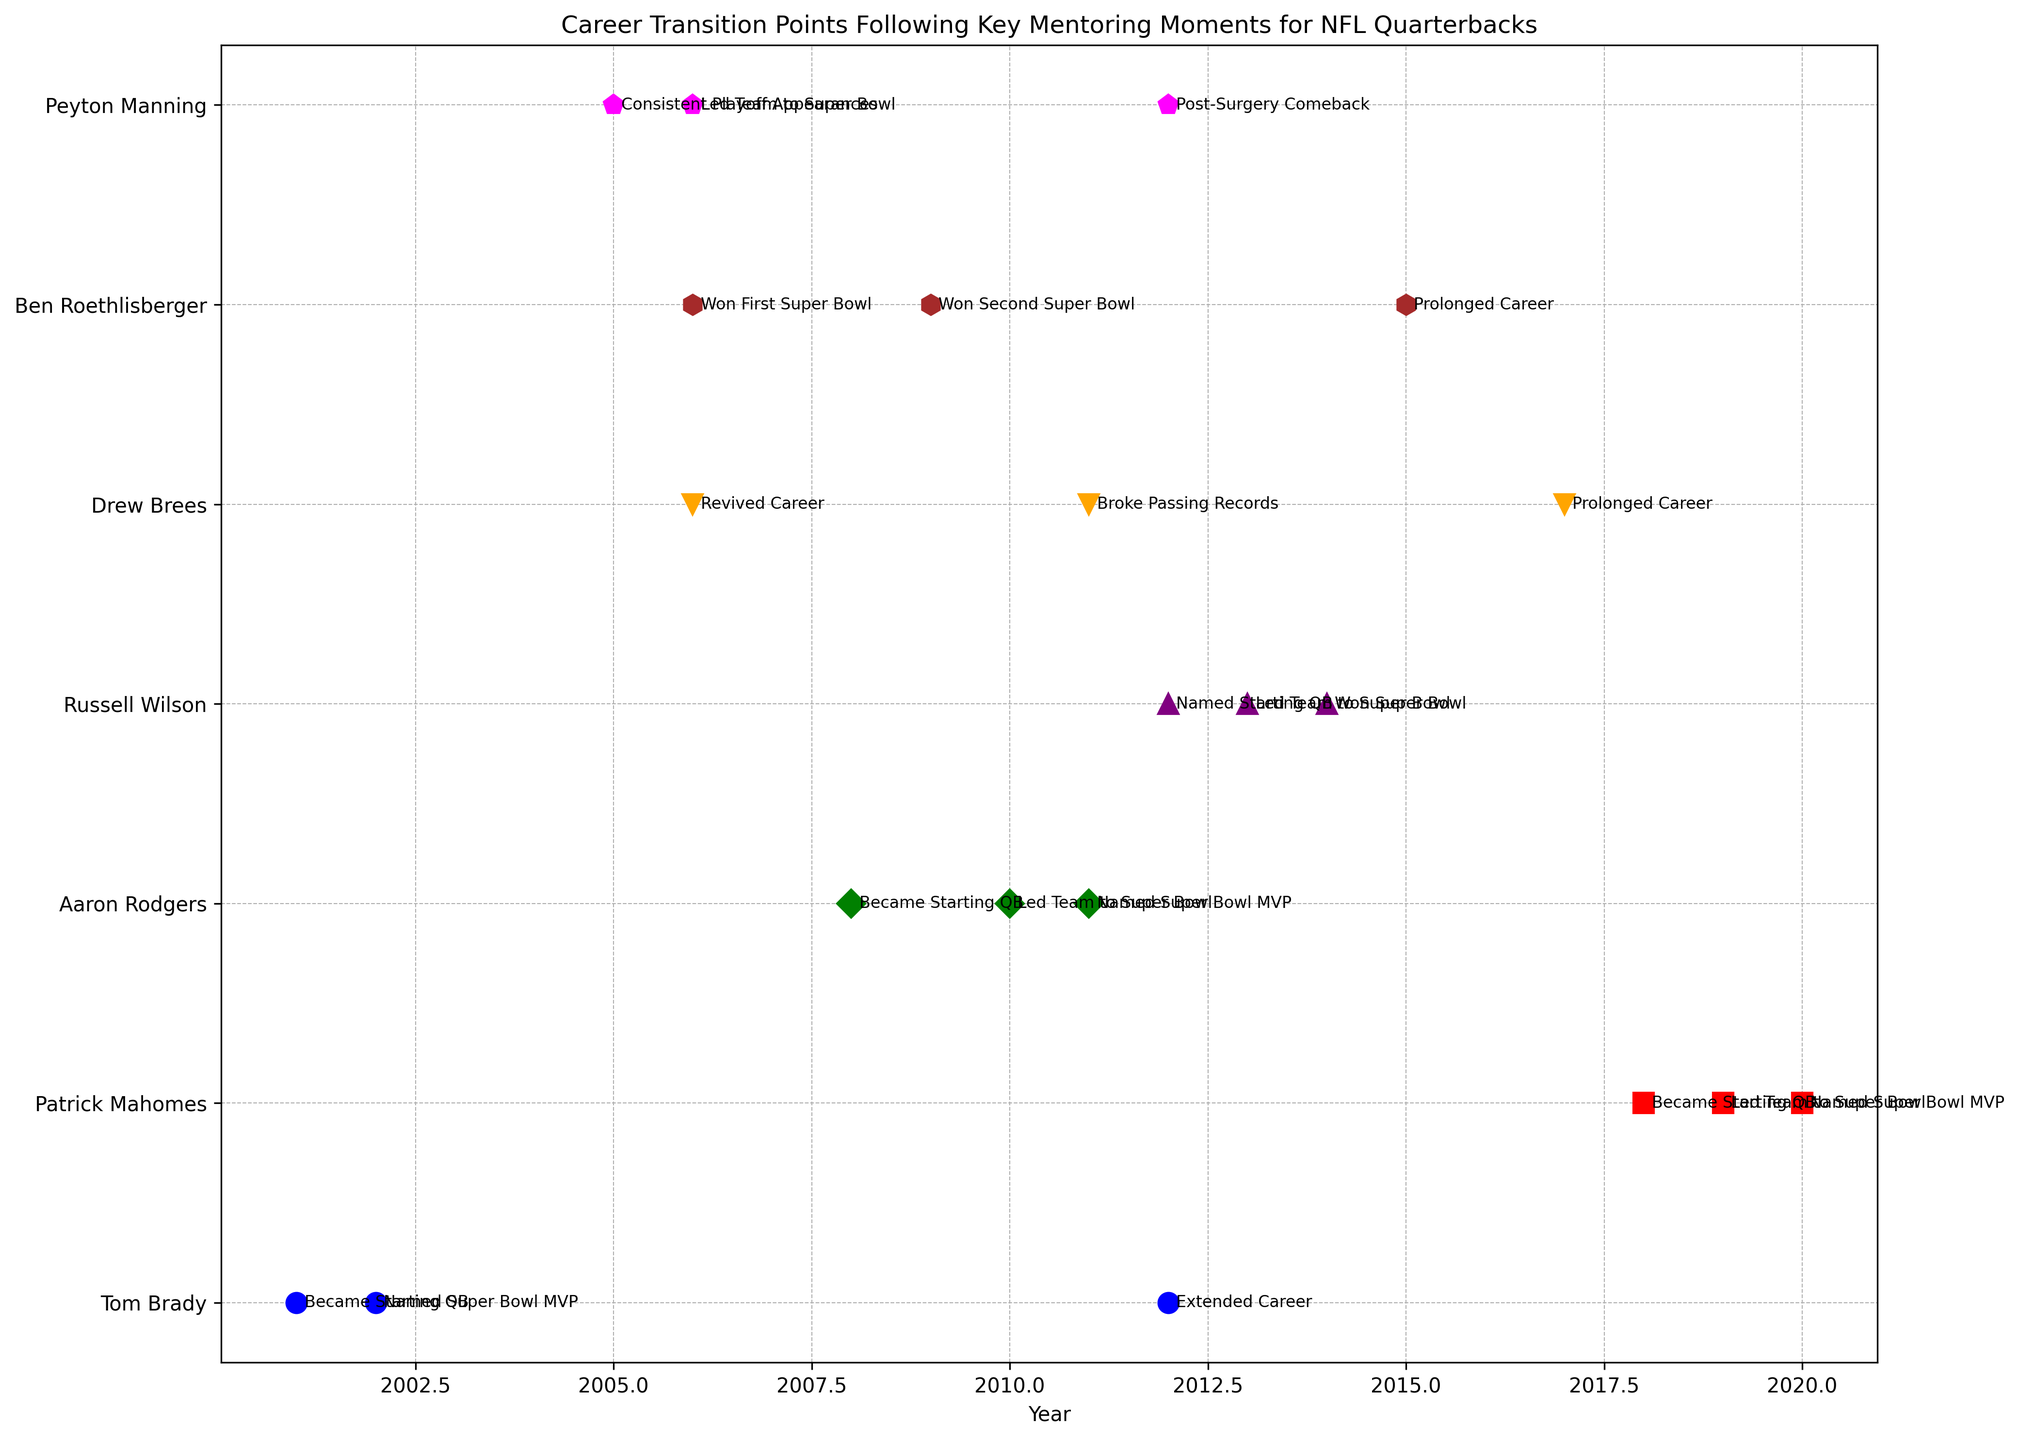What was the first career transition point for Tom Brady? The figure shows that Tom Brady's first transition point followed his first meeting with Belichick in 2001, where he became the starting quarterback.
Answer: Became Starting QB Which player reached a Super Bowl appearance first, Ben Roethlisberger or Drew Brees? By examining the timeline, Drew Brees' revival came in 2006 after coaching from Sean Payton, but he led the team to the Super Bowl later in his career. Ben Roethlisberger, on the other hand, won his first Super Bowl in 2006. Hence, Ben reached the Super Bowl first.
Answer: Ben Roethlisberger How many years after his first mentoring moment did Patrick Mahomes achieve his Super Bowl MVP title? Patrick Mahomes' first mentoring moment was with Alex Smith in 2018. He became Super Bowl MVP in 2020. The difference between these years is 2020 - 2018 = 2 years.
Answer: 2 years Which player had the earliest recorded career transition point in the figure? The earliest transition points per the timeline in the figure are associated with Tom Brady in 2001 following his first meeting with Belichick.
Answer: Tom Brady Whose career revival was marked by mentoring from a coach in 2006? The figure indicates Drew Brees' career revival was facilitated by coaching from Sean Payton in 2006.
Answer: Drew Brees Who became a starting QB after receiving mentorship from a previous star quarterback, and what year did this happen? The figure shows both Patrick Mahomes and Aaron Rodgers receiving mentorship from Alex Smith and Brett Favre, respectively. Mahomes became a starting QB in 2018, and Rodgers in 2008.
Answer: Aaron Rodgers, 2008 Which player had the most mentoring moments contributing to career transitions in their timeline? By counting the instances, it appears both Tom Brady and Ben Roethlisberger had three distinct mentoring moments leading to career transitions, making them the players with the most mentoring moments.
Answer: Tom Brady and Ben Roethlisberger Whose mentoring moment led directly to a Super Bowl victory, and what advice did they receive? Russell Wilson received guidance on leadership from Pete Carroll, which led to his team winning the Super Bowl in 2014.
Answer: Russell Wilson, Guidance on Leadership What was Peyton Manning’s career transition following advice on film study, and in which year did it occur? The figure indicates that Peyton Manning's advice on film study led to him guiding his team to the Super Bowl in 2006.
Answer: Led Team to Super Bowl, 2006 Compare the colors used for Tom Brady's and Patrick Mahomes' markers. Tom Brady’s markers are shown in blue, while Patrick Mahomes’ markers are displayed in red, highlighting their distinct plot visualizations.
Answer: Blue (Tom Brady) and Red (Patrick Mahomes) 